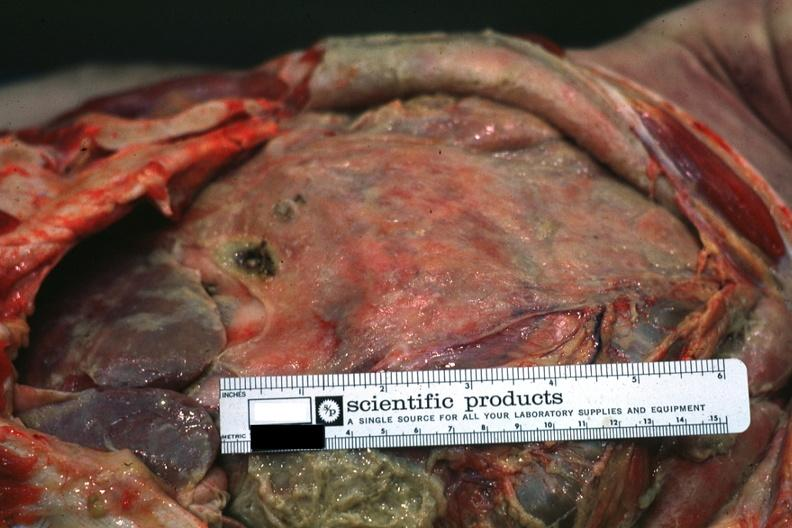s acute peritonitis present?
Answer the question using a single word or phrase. Yes 